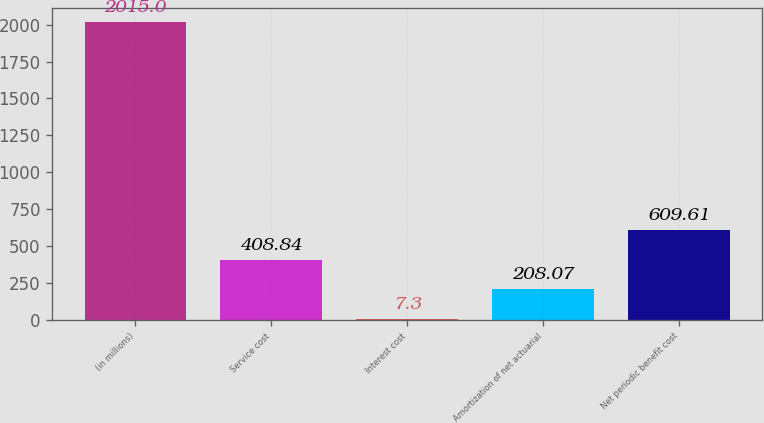<chart> <loc_0><loc_0><loc_500><loc_500><bar_chart><fcel>(in millions)<fcel>Service cost<fcel>Interest cost<fcel>Amortization of net actuarial<fcel>Net periodic benefit cost<nl><fcel>2015<fcel>408.84<fcel>7.3<fcel>208.07<fcel>609.61<nl></chart> 